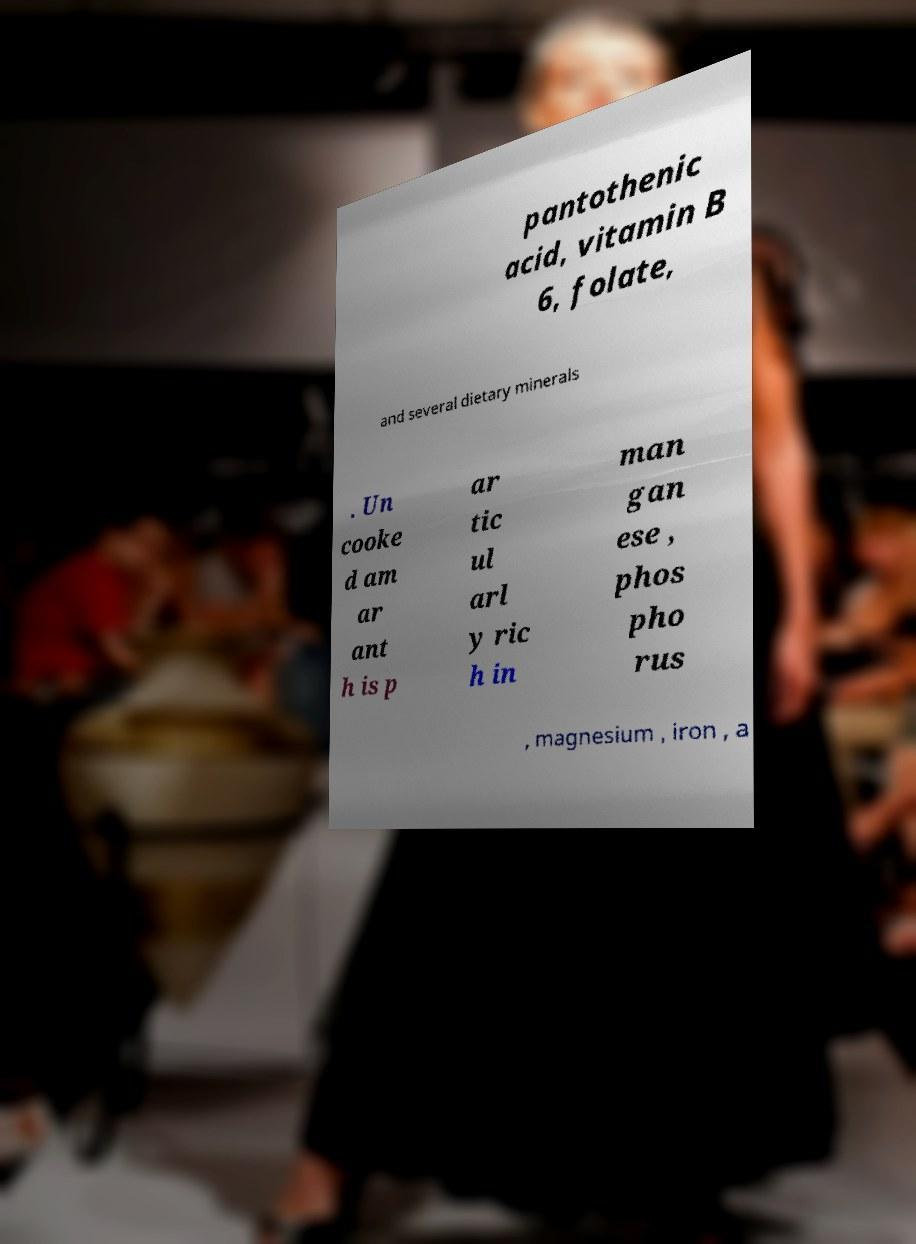I need the written content from this picture converted into text. Can you do that? pantothenic acid, vitamin B 6, folate, and several dietary minerals . Un cooke d am ar ant h is p ar tic ul arl y ric h in man gan ese , phos pho rus , magnesium , iron , a 